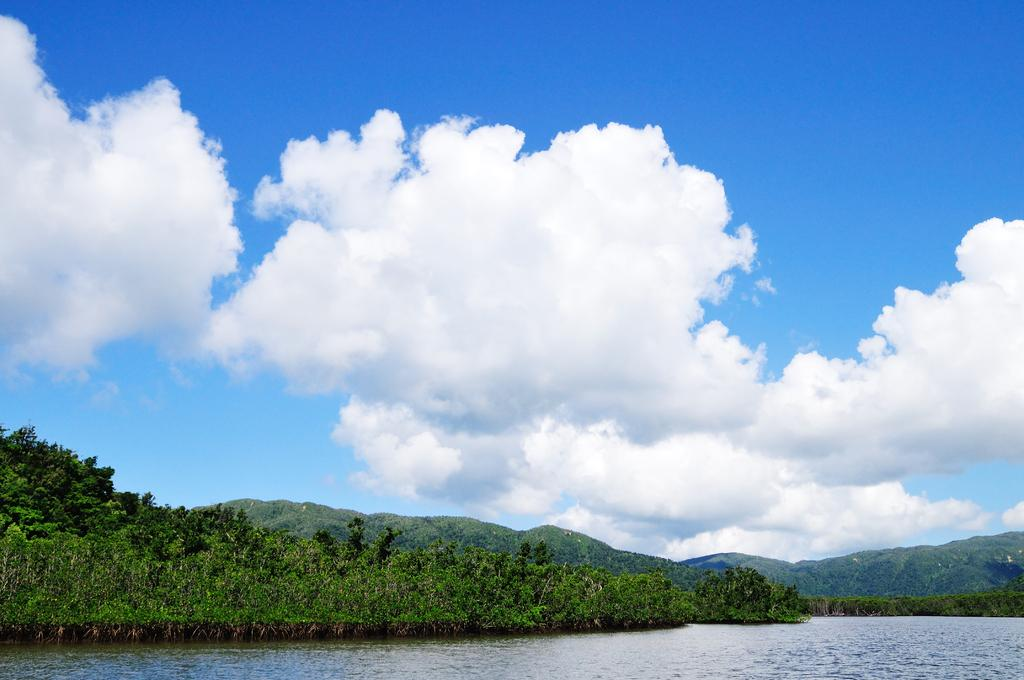Where was the picture taken? The picture was clicked outside. What can be seen in the foreground of the image? There is a water body and plants in the foreground of the image. What is visible in the background of the image? The sky and hills are visible in the background of the image. What is the condition of the sky in the image? The sky is full of clouds in the image. What type of rice is being harvested in the image? There is no rice or harvesting activity present in the image. How many people are in the crowd in the image? There is no crowd present in the image. 